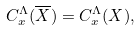Convert formula to latex. <formula><loc_0><loc_0><loc_500><loc_500>C _ { x } ^ { \Lambda } ( \overline { X } ) = C _ { x } ^ { \Lambda } ( X ) ,</formula> 